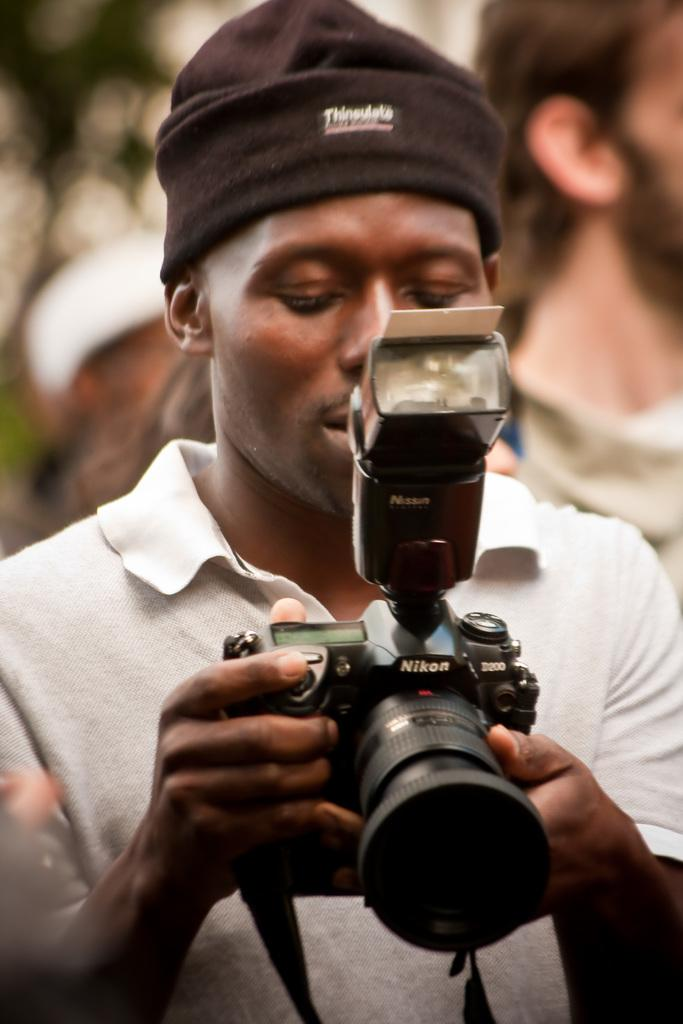<image>
Write a terse but informative summary of the picture. A photographer aiming his Nikon camera towards the ground. 